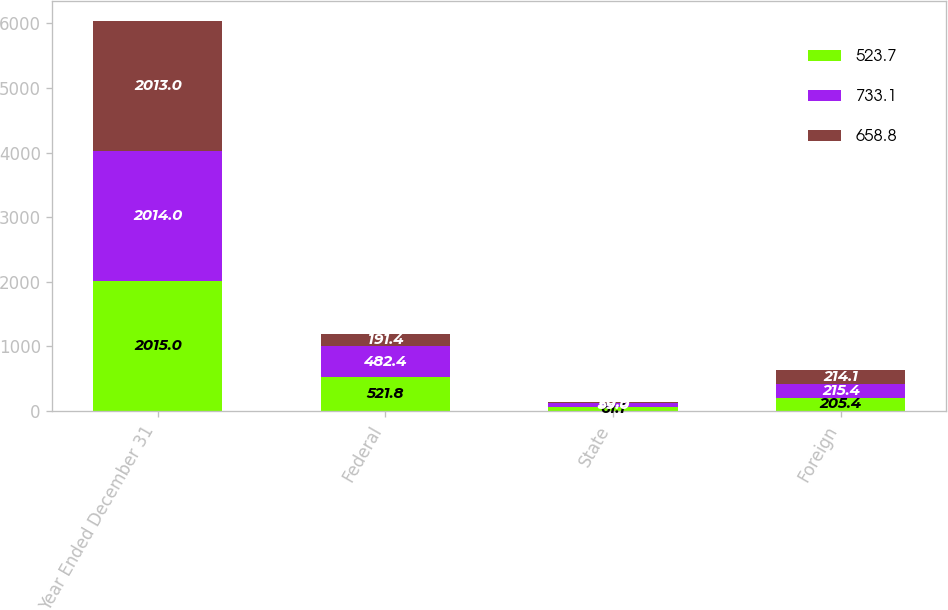Convert chart. <chart><loc_0><loc_0><loc_500><loc_500><stacked_bar_chart><ecel><fcel>Year Ended December 31<fcel>Federal<fcel>State<fcel>Foreign<nl><fcel>523.7<fcel>2015<fcel>521.8<fcel>61.1<fcel>205.4<nl><fcel>733.1<fcel>2014<fcel>482.4<fcel>59<fcel>215.4<nl><fcel>658.8<fcel>2013<fcel>191.4<fcel>20.9<fcel>214.1<nl></chart> 